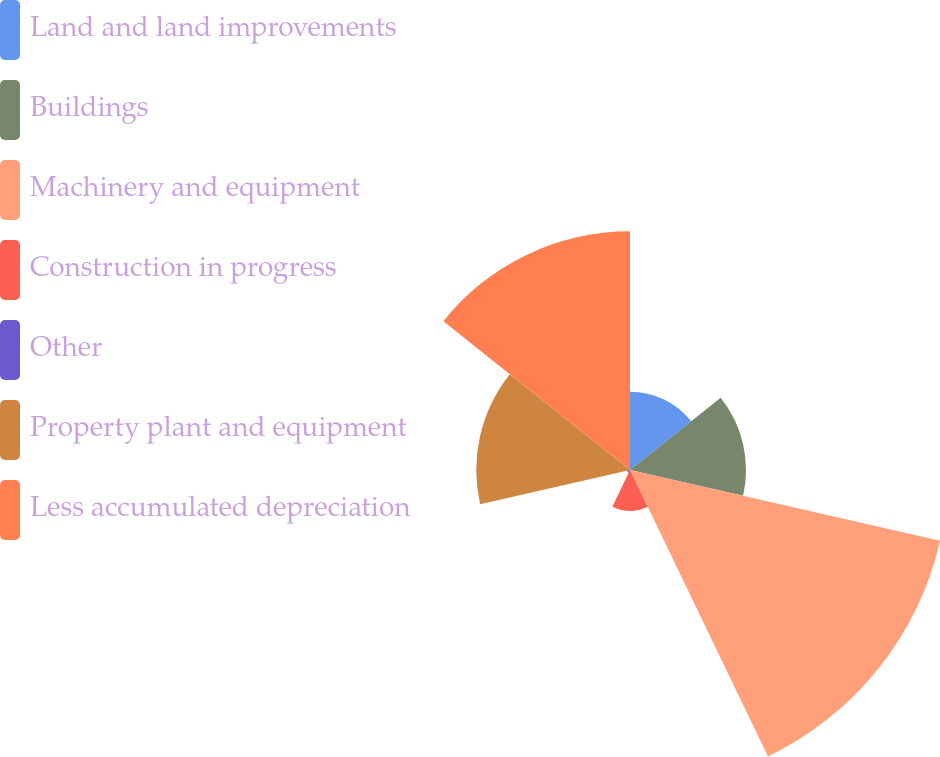Convert chart. <chart><loc_0><loc_0><loc_500><loc_500><pie_chart><fcel>Land and land improvements<fcel>Buildings<fcel>Machinery and equipment<fcel>Construction in progress<fcel>Other<fcel>Property plant and equipment<fcel>Less accumulated depreciation<nl><fcel>8.26%<fcel>12.23%<fcel>33.53%<fcel>4.29%<fcel>0.32%<fcel>16.21%<fcel>25.17%<nl></chart> 